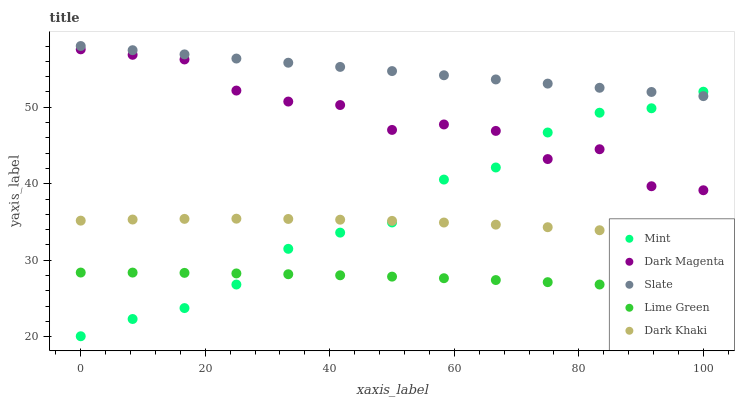Does Lime Green have the minimum area under the curve?
Answer yes or no. Yes. Does Slate have the maximum area under the curve?
Answer yes or no. Yes. Does Slate have the minimum area under the curve?
Answer yes or no. No. Does Lime Green have the maximum area under the curve?
Answer yes or no. No. Is Slate the smoothest?
Answer yes or no. Yes. Is Dark Magenta the roughest?
Answer yes or no. Yes. Is Lime Green the smoothest?
Answer yes or no. No. Is Lime Green the roughest?
Answer yes or no. No. Does Mint have the lowest value?
Answer yes or no. Yes. Does Lime Green have the lowest value?
Answer yes or no. No. Does Slate have the highest value?
Answer yes or no. Yes. Does Lime Green have the highest value?
Answer yes or no. No. Is Dark Khaki less than Dark Magenta?
Answer yes or no. Yes. Is Dark Magenta greater than Lime Green?
Answer yes or no. Yes. Does Dark Khaki intersect Mint?
Answer yes or no. Yes. Is Dark Khaki less than Mint?
Answer yes or no. No. Is Dark Khaki greater than Mint?
Answer yes or no. No. Does Dark Khaki intersect Dark Magenta?
Answer yes or no. No. 